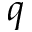Convert formula to latex. <formula><loc_0><loc_0><loc_500><loc_500>q</formula> 